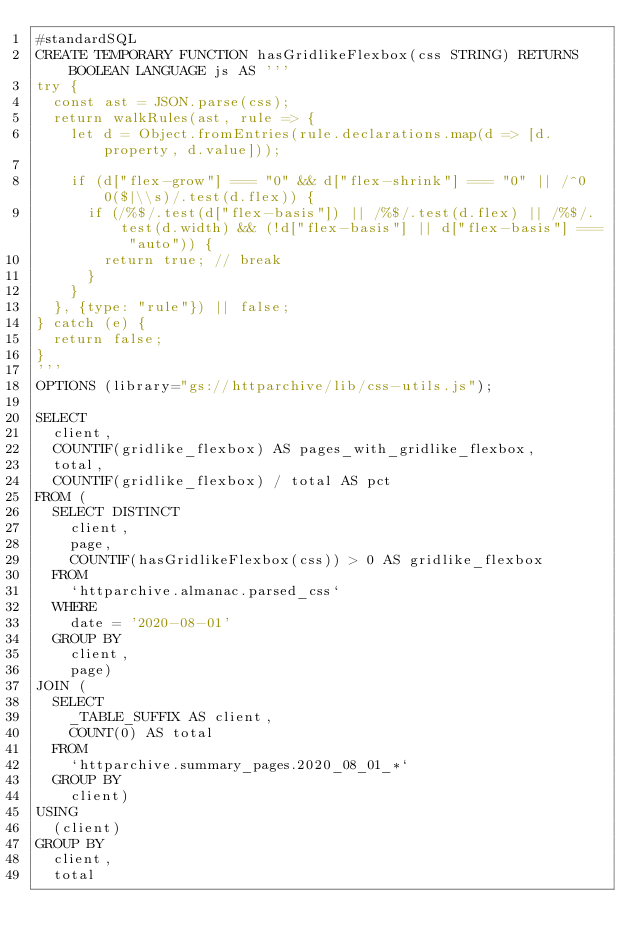<code> <loc_0><loc_0><loc_500><loc_500><_SQL_>#standardSQL
CREATE TEMPORARY FUNCTION hasGridlikeFlexbox(css STRING) RETURNS BOOLEAN LANGUAGE js AS '''
try {
  const ast = JSON.parse(css);
  return walkRules(ast, rule => {
    let d = Object.fromEntries(rule.declarations.map(d => [d.property, d.value]));

    if (d["flex-grow"] === "0" && d["flex-shrink"] === "0" || /^0 0($|\\s)/.test(d.flex)) {
      if (/%$/.test(d["flex-basis"]) || /%$/.test(d.flex) || /%$/.test(d.width) && (!d["flex-basis"] || d["flex-basis"] === "auto")) {
        return true; // break
      }
    }
  }, {type: "rule"}) || false;
} catch (e) {
  return false;
}
'''
OPTIONS (library="gs://httparchive/lib/css-utils.js");

SELECT
  client,
  COUNTIF(gridlike_flexbox) AS pages_with_gridlike_flexbox,
  total,
  COUNTIF(gridlike_flexbox) / total AS pct
FROM (
  SELECT DISTINCT
    client,
    page,
    COUNTIF(hasGridlikeFlexbox(css)) > 0 AS gridlike_flexbox
  FROM
    `httparchive.almanac.parsed_css`
  WHERE
    date = '2020-08-01'
  GROUP BY
    client,
    page)
JOIN (
  SELECT
    _TABLE_SUFFIX AS client,
    COUNT(0) AS total
  FROM
    `httparchive.summary_pages.2020_08_01_*`
  GROUP BY
    client)
USING
  (client)
GROUP BY
  client,
  total</code> 